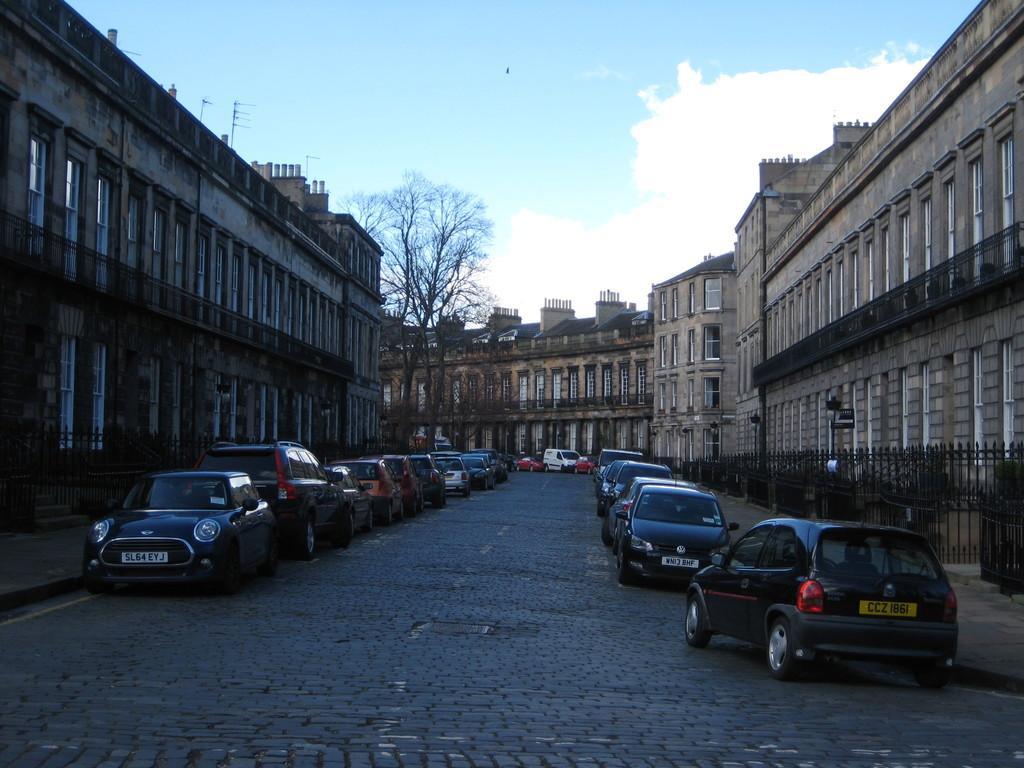Can you describe this image briefly? In this picture we can see vehicles on the road, trees, fences, buildings with windows and some objects and in the background we can see the sky with clouds. 